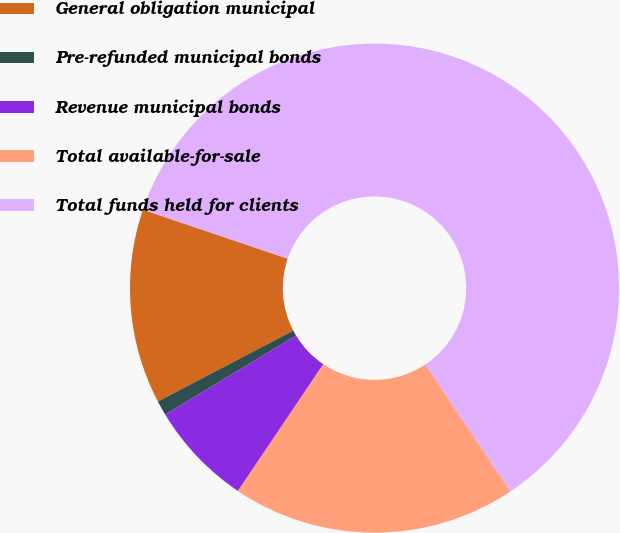Convert chart to OTSL. <chart><loc_0><loc_0><loc_500><loc_500><pie_chart><fcel>General obligation municipal<fcel>Pre-refunded municipal bonds<fcel>Revenue municipal bonds<fcel>Total available-for-sale<fcel>Total funds held for clients<nl><fcel>12.87%<fcel>0.98%<fcel>6.92%<fcel>18.81%<fcel>60.42%<nl></chart> 